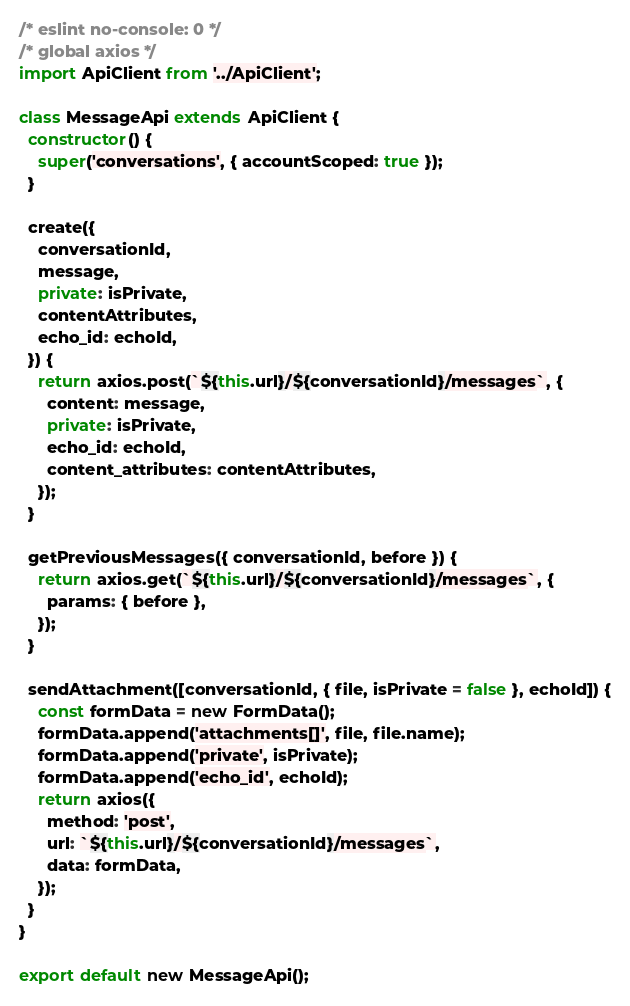Convert code to text. <code><loc_0><loc_0><loc_500><loc_500><_JavaScript_>/* eslint no-console: 0 */
/* global axios */
import ApiClient from '../ApiClient';

class MessageApi extends ApiClient {
  constructor() {
    super('conversations', { accountScoped: true });
  }

  create({
    conversationId,
    message,
    private: isPrivate,
    contentAttributes,
    echo_id: echoId,
  }) {
    return axios.post(`${this.url}/${conversationId}/messages`, {
      content: message,
      private: isPrivate,
      echo_id: echoId,
      content_attributes: contentAttributes,
    });
  }

  getPreviousMessages({ conversationId, before }) {
    return axios.get(`${this.url}/${conversationId}/messages`, {
      params: { before },
    });
  }

  sendAttachment([conversationId, { file, isPrivate = false }, echoId]) {
    const formData = new FormData();
    formData.append('attachments[]', file, file.name);
    formData.append('private', isPrivate);
    formData.append('echo_id', echoId);
    return axios({
      method: 'post',
      url: `${this.url}/${conversationId}/messages`,
      data: formData,
    });
  }
}

export default new MessageApi();
</code> 